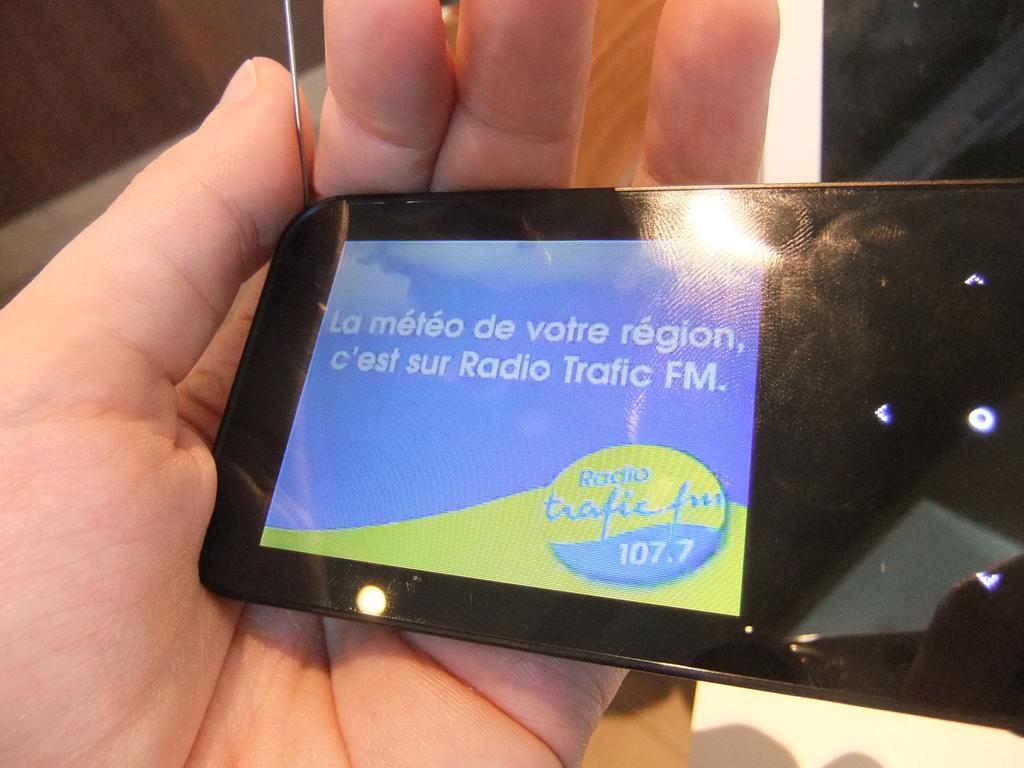What radio station is seen here?
Offer a terse response. 107.7. Is the radio station fm or am?
Make the answer very short. Fm. 